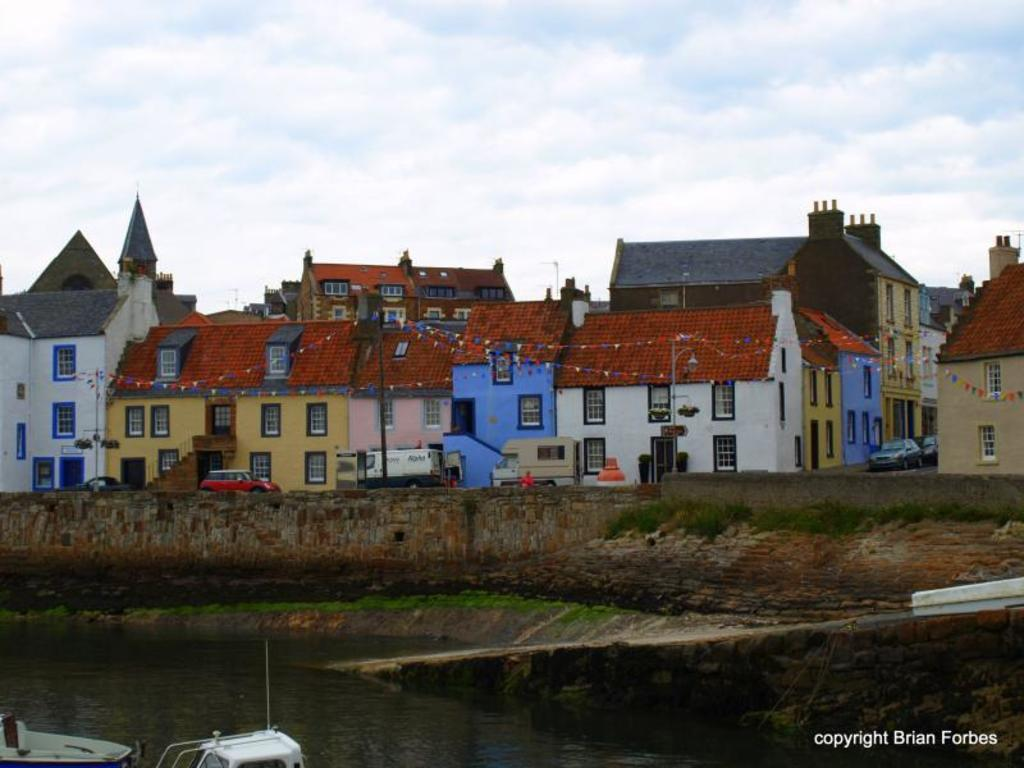What can be seen floating on the water in the image? There are two small boats in the pond in the image. What type of structures can be seen in the background? Homes are visible in the background of the image. What is moving on the road in front of the homes? Vehicles are present on the road in front of the homes. What is visible above the homes and boats? The sky is visible in the image, and clouds are present in the sky. What type of plantation can be seen in the image? There is no plantation present in the image; it features a pond with boats, homes, vehicles, and a sky with clouds. 